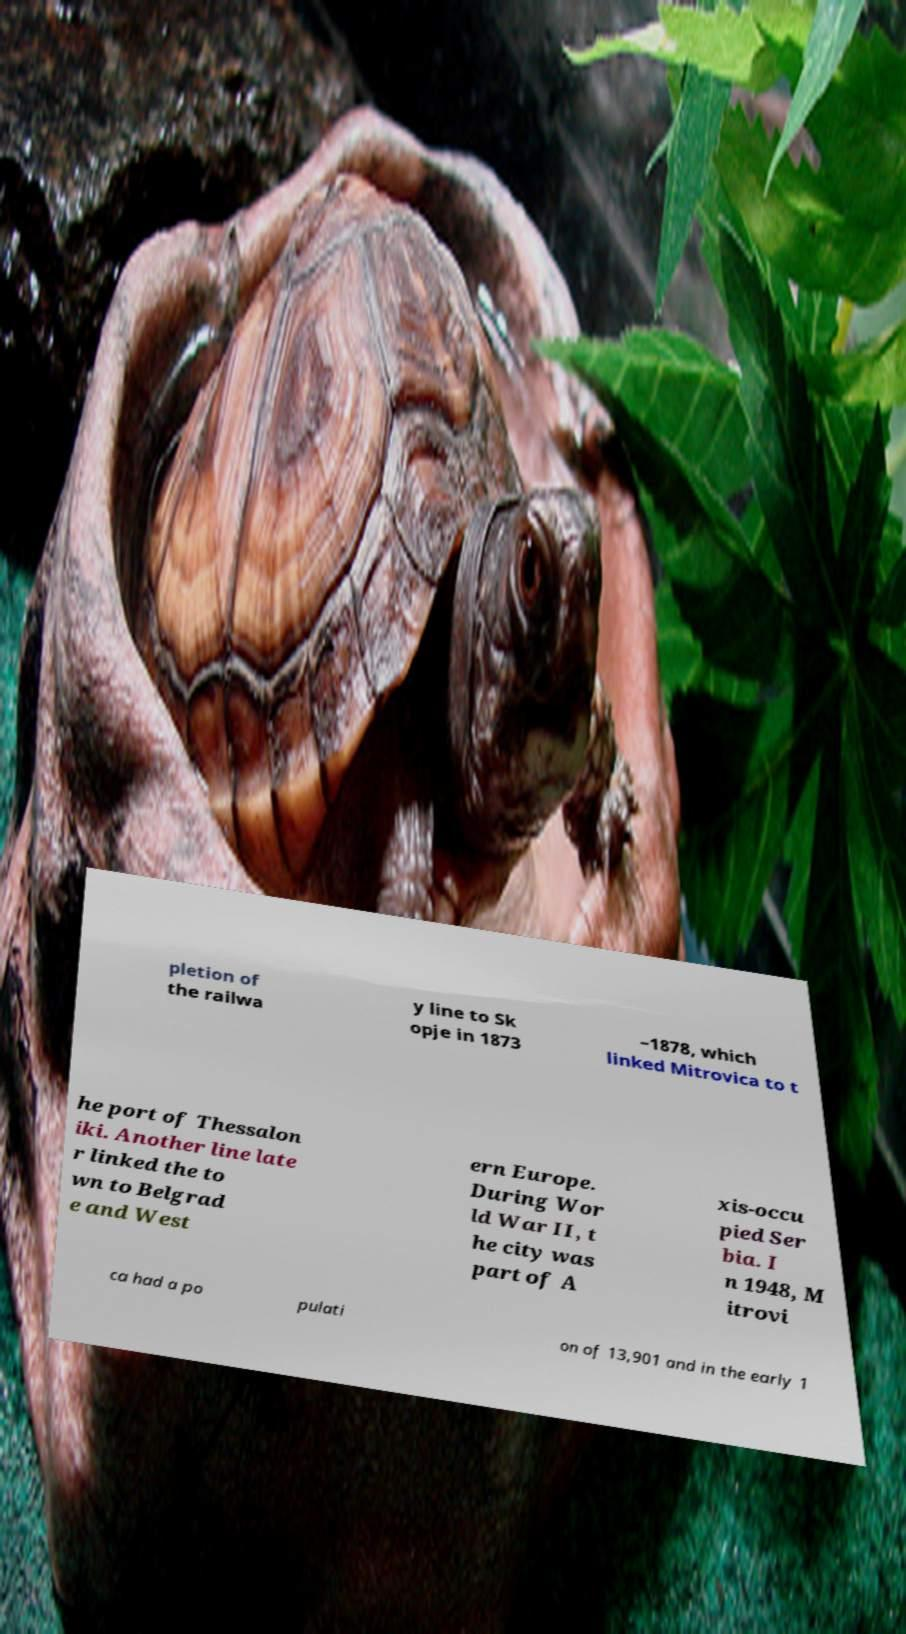There's text embedded in this image that I need extracted. Can you transcribe it verbatim? pletion of the railwa y line to Sk opje in 1873 –1878, which linked Mitrovica to t he port of Thessalon iki. Another line late r linked the to wn to Belgrad e and West ern Europe. During Wor ld War II, t he city was part of A xis-occu pied Ser bia. I n 1948, M itrovi ca had a po pulati on of 13,901 and in the early 1 